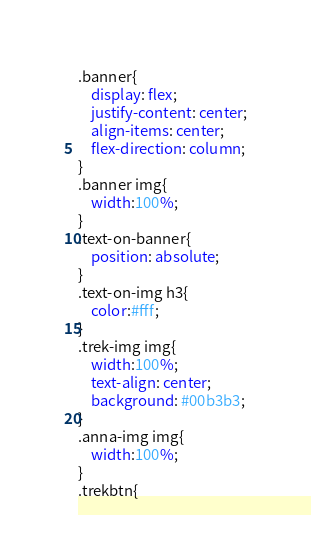<code> <loc_0><loc_0><loc_500><loc_500><_CSS_>.banner{
	display: flex;
	justify-content: center;
	align-items: center;
	flex-direction: column;
}
.banner img{
	width:100%;
}
.text-on-banner{
	position: absolute;
}
.text-on-img h3{
	color:#fff;
}
.trek-img img{
	width:100%;
	text-align: center;
	background: #00b3b3;
}
.anna-img img{
	width:100%;
}
.trekbtn{</code> 